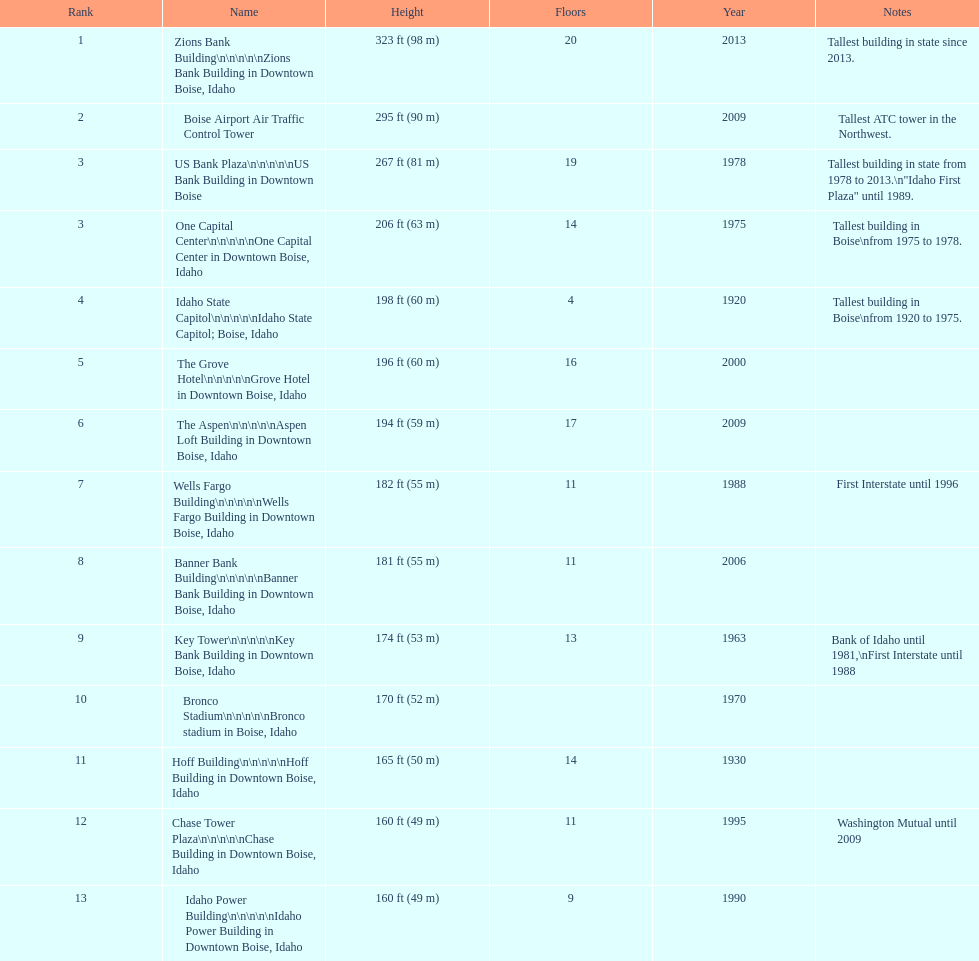How many of these buildings were built after 1975 8. 